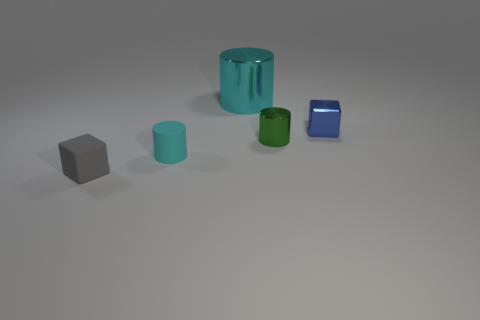What color is the cylinder behind the tiny blue metal object?
Offer a very short reply. Cyan. How many small rubber things are the same color as the small matte cube?
Your response must be concise. 0. How many cyan cylinders are in front of the green cylinder and behind the tiny blue cube?
Give a very brief answer. 0. There is a cyan rubber object that is the same size as the green metallic thing; what is its shape?
Your answer should be very brief. Cylinder. How big is the gray object?
Give a very brief answer. Small. There is a cylinder behind the tiny cube that is behind the small cylinder that is left of the cyan metal cylinder; what is its material?
Ensure brevity in your answer.  Metal. There is a tiny block that is the same material as the tiny green cylinder; what color is it?
Make the answer very short. Blue. There is a tiny matte object behind the tiny thing to the left of the small cyan matte cylinder; how many cyan metallic cylinders are left of it?
Your answer should be very brief. 0. What material is the other object that is the same color as the big thing?
Offer a very short reply. Rubber. Is there any other thing that is the same shape as the green thing?
Give a very brief answer. Yes. 